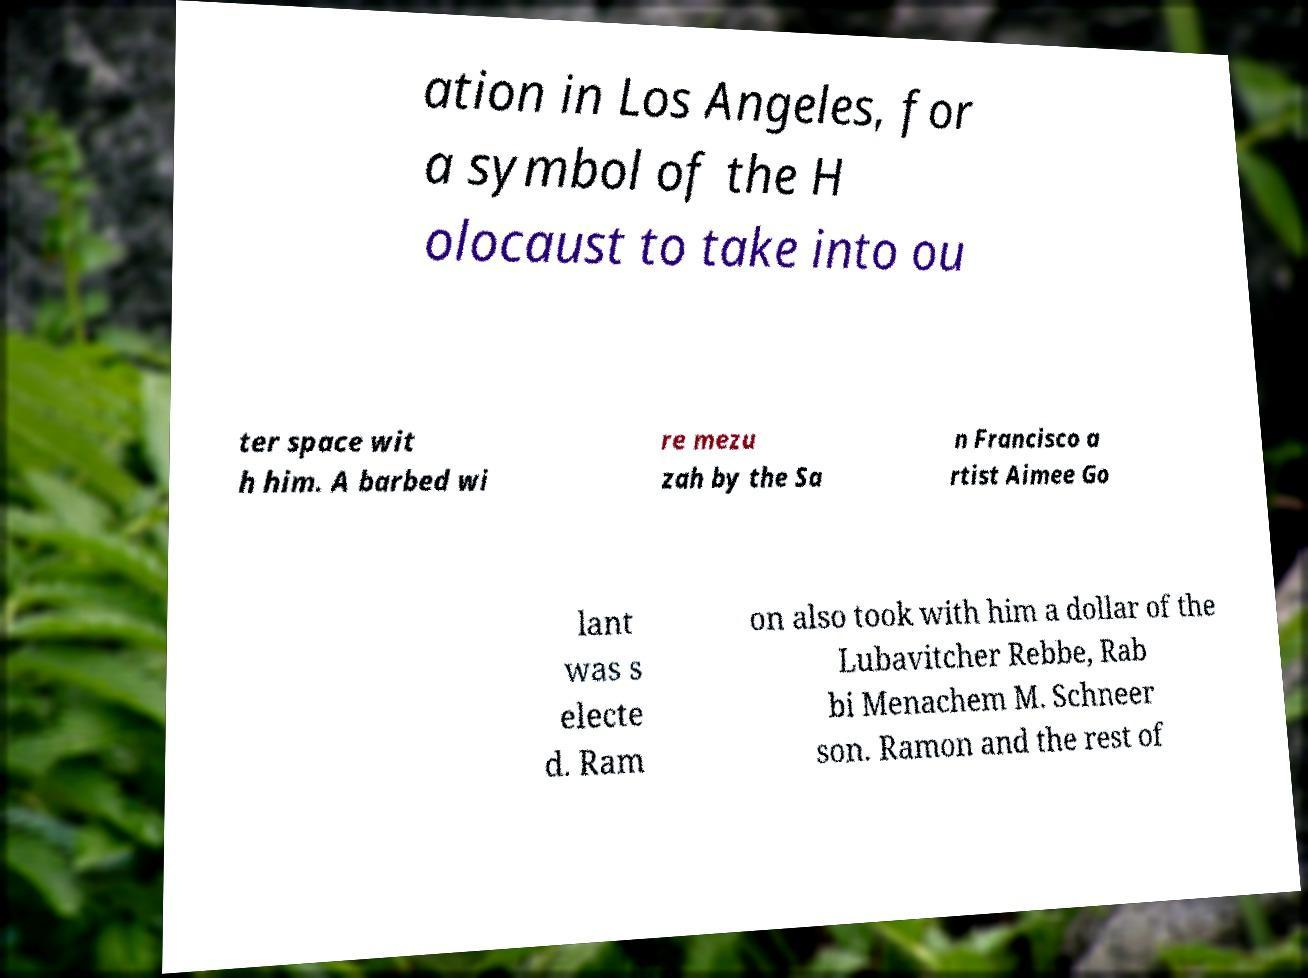Could you extract and type out the text from this image? ation in Los Angeles, for a symbol of the H olocaust to take into ou ter space wit h him. A barbed wi re mezu zah by the Sa n Francisco a rtist Aimee Go lant was s electe d. Ram on also took with him a dollar of the Lubavitcher Rebbe, Rab bi Menachem M. Schneer son. Ramon and the rest of 